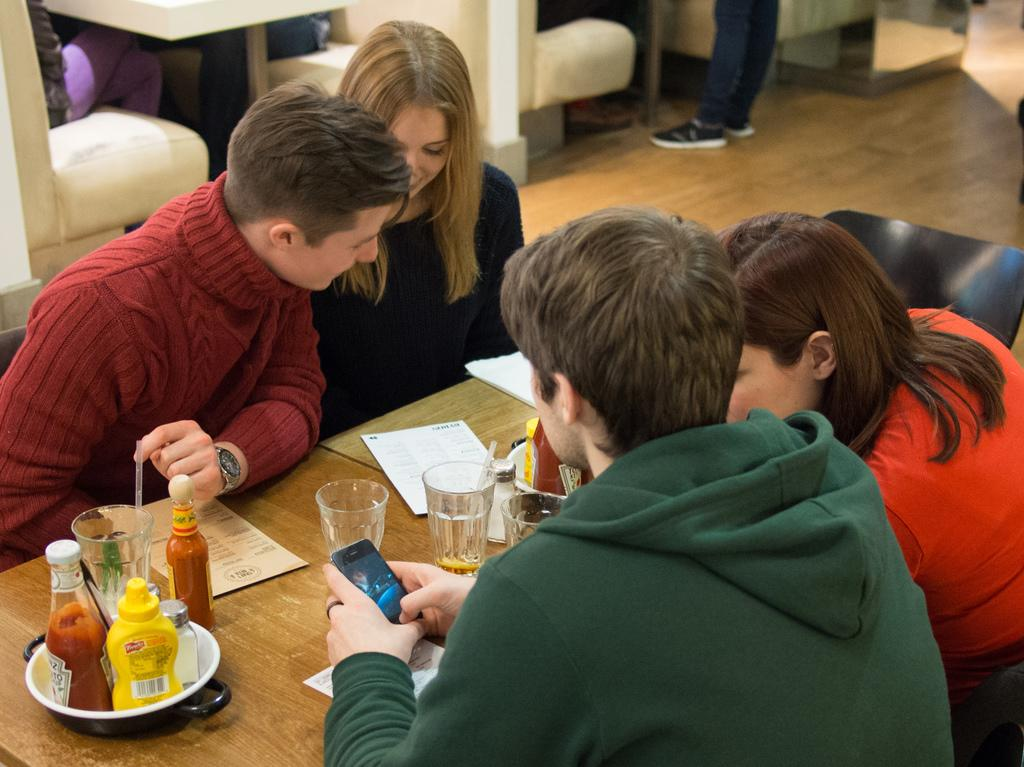How many people are present in the image? There are four people in the image. What are the people doing in the image? The people are sitting on chairs. What is in front of the chairs? There is a table in front of the chairs. What items can be seen on the table? There is a paper, a book, glasses, and bottles on the table. What type of teeth can be seen on the stage in the image? There is no stage or teeth present in the image. 